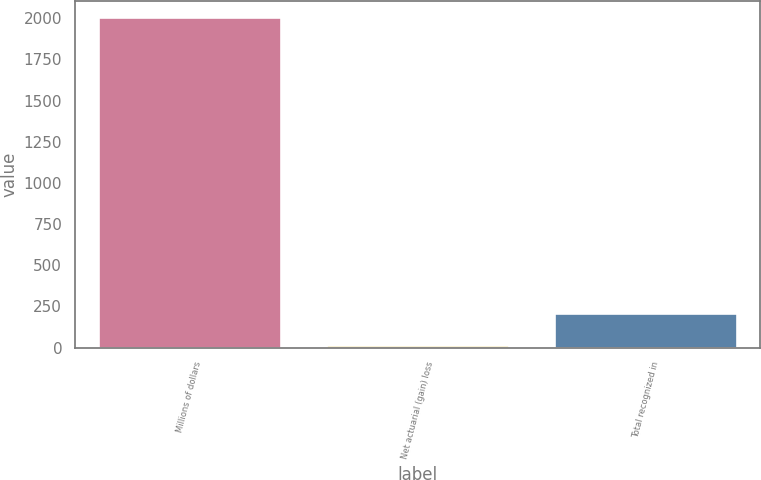Convert chart to OTSL. <chart><loc_0><loc_0><loc_500><loc_500><bar_chart><fcel>Millions of dollars<fcel>Net actuarial (gain) loss<fcel>Total recognized in<nl><fcel>2007<fcel>13<fcel>212.4<nl></chart> 